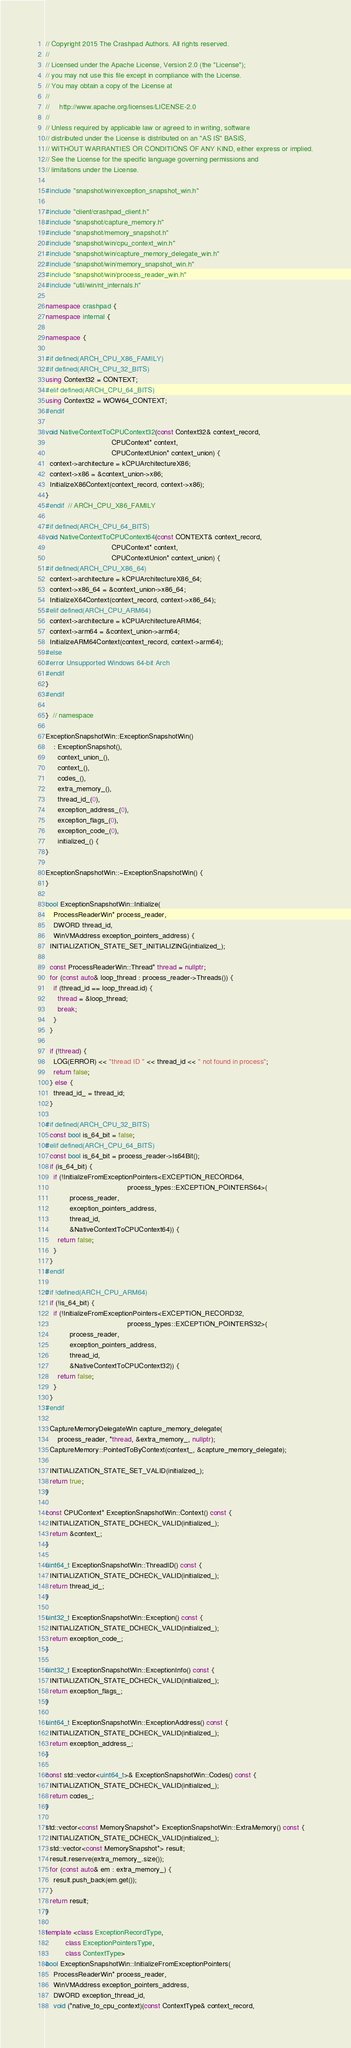Convert code to text. <code><loc_0><loc_0><loc_500><loc_500><_C++_>// Copyright 2015 The Crashpad Authors. All rights reserved.
//
// Licensed under the Apache License, Version 2.0 (the "License");
// you may not use this file except in compliance with the License.
// You may obtain a copy of the License at
//
//     http://www.apache.org/licenses/LICENSE-2.0
//
// Unless required by applicable law or agreed to in writing, software
// distributed under the License is distributed on an "AS IS" BASIS,
// WITHOUT WARRANTIES OR CONDITIONS OF ANY KIND, either express or implied.
// See the License for the specific language governing permissions and
// limitations under the License.

#include "snapshot/win/exception_snapshot_win.h"

#include "client/crashpad_client.h"
#include "snapshot/capture_memory.h"
#include "snapshot/memory_snapshot.h"
#include "snapshot/win/cpu_context_win.h"
#include "snapshot/win/capture_memory_delegate_win.h"
#include "snapshot/win/memory_snapshot_win.h"
#include "snapshot/win/process_reader_win.h"
#include "util/win/nt_internals.h"

namespace crashpad {
namespace internal {

namespace {

#if defined(ARCH_CPU_X86_FAMILY)
#if defined(ARCH_CPU_32_BITS)
using Context32 = CONTEXT;
#elif defined(ARCH_CPU_64_BITS)
using Context32 = WOW64_CONTEXT;
#endif

void NativeContextToCPUContext32(const Context32& context_record,
                                 CPUContext* context,
                                 CPUContextUnion* context_union) {
  context->architecture = kCPUArchitectureX86;
  context->x86 = &context_union->x86;
  InitializeX86Context(context_record, context->x86);
}
#endif  // ARCH_CPU_X86_FAMILY

#if defined(ARCH_CPU_64_BITS)
void NativeContextToCPUContext64(const CONTEXT& context_record,
                                 CPUContext* context,
                                 CPUContextUnion* context_union) {
#if defined(ARCH_CPU_X86_64)
  context->architecture = kCPUArchitectureX86_64;
  context->x86_64 = &context_union->x86_64;
  InitializeX64Context(context_record, context->x86_64);
#elif defined(ARCH_CPU_ARM64)
  context->architecture = kCPUArchitectureARM64;
  context->arm64 = &context_union->arm64;
  InitializeARM64Context(context_record, context->arm64);
#else
#error Unsupported Windows 64-bit Arch
#endif
}
#endif

}  // namespace

ExceptionSnapshotWin::ExceptionSnapshotWin()
    : ExceptionSnapshot(),
      context_union_(),
      context_(),
      codes_(),
      extra_memory_(),
      thread_id_(0),
      exception_address_(0),
      exception_flags_(0),
      exception_code_(0),
      initialized_() {
}

ExceptionSnapshotWin::~ExceptionSnapshotWin() {
}

bool ExceptionSnapshotWin::Initialize(
    ProcessReaderWin* process_reader,
    DWORD thread_id,
    WinVMAddress exception_pointers_address) {
  INITIALIZATION_STATE_SET_INITIALIZING(initialized_);

  const ProcessReaderWin::Thread* thread = nullptr;
  for (const auto& loop_thread : process_reader->Threads()) {
    if (thread_id == loop_thread.id) {
      thread = &loop_thread;
      break;
    }
  }

  if (!thread) {
    LOG(ERROR) << "thread ID " << thread_id << " not found in process";
    return false;
  } else {
    thread_id_ = thread_id;
  }

#if defined(ARCH_CPU_32_BITS)
  const bool is_64_bit = false;
#elif defined(ARCH_CPU_64_BITS)
  const bool is_64_bit = process_reader->Is64Bit();
  if (is_64_bit) {
    if (!InitializeFromExceptionPointers<EXCEPTION_RECORD64,
                                         process_types::EXCEPTION_POINTERS64>(
            process_reader,
            exception_pointers_address,
            thread_id,
            &NativeContextToCPUContext64)) {
      return false;
    }
  }
#endif

#if !defined(ARCH_CPU_ARM64)
  if (!is_64_bit) {
    if (!InitializeFromExceptionPointers<EXCEPTION_RECORD32,
                                         process_types::EXCEPTION_POINTERS32>(
            process_reader,
            exception_pointers_address,
            thread_id,
            &NativeContextToCPUContext32)) {
      return false;
    }
  }
#endif

  CaptureMemoryDelegateWin capture_memory_delegate(
      process_reader, *thread, &extra_memory_, nullptr);
  CaptureMemory::PointedToByContext(context_, &capture_memory_delegate);

  INITIALIZATION_STATE_SET_VALID(initialized_);
  return true;
}

const CPUContext* ExceptionSnapshotWin::Context() const {
  INITIALIZATION_STATE_DCHECK_VALID(initialized_);
  return &context_;
}

uint64_t ExceptionSnapshotWin::ThreadID() const {
  INITIALIZATION_STATE_DCHECK_VALID(initialized_);
  return thread_id_;
}

uint32_t ExceptionSnapshotWin::Exception() const {
  INITIALIZATION_STATE_DCHECK_VALID(initialized_);
  return exception_code_;
}

uint32_t ExceptionSnapshotWin::ExceptionInfo() const {
  INITIALIZATION_STATE_DCHECK_VALID(initialized_);
  return exception_flags_;
}

uint64_t ExceptionSnapshotWin::ExceptionAddress() const {
  INITIALIZATION_STATE_DCHECK_VALID(initialized_);
  return exception_address_;
}

const std::vector<uint64_t>& ExceptionSnapshotWin::Codes() const {
  INITIALIZATION_STATE_DCHECK_VALID(initialized_);
  return codes_;
}

std::vector<const MemorySnapshot*> ExceptionSnapshotWin::ExtraMemory() const {
  INITIALIZATION_STATE_DCHECK_VALID(initialized_);
  std::vector<const MemorySnapshot*> result;
  result.reserve(extra_memory_.size());
  for (const auto& em : extra_memory_) {
    result.push_back(em.get());
  }
  return result;
}

template <class ExceptionRecordType,
          class ExceptionPointersType,
          class ContextType>
bool ExceptionSnapshotWin::InitializeFromExceptionPointers(
    ProcessReaderWin* process_reader,
    WinVMAddress exception_pointers_address,
    DWORD exception_thread_id,
    void (*native_to_cpu_context)(const ContextType& context_record,</code> 